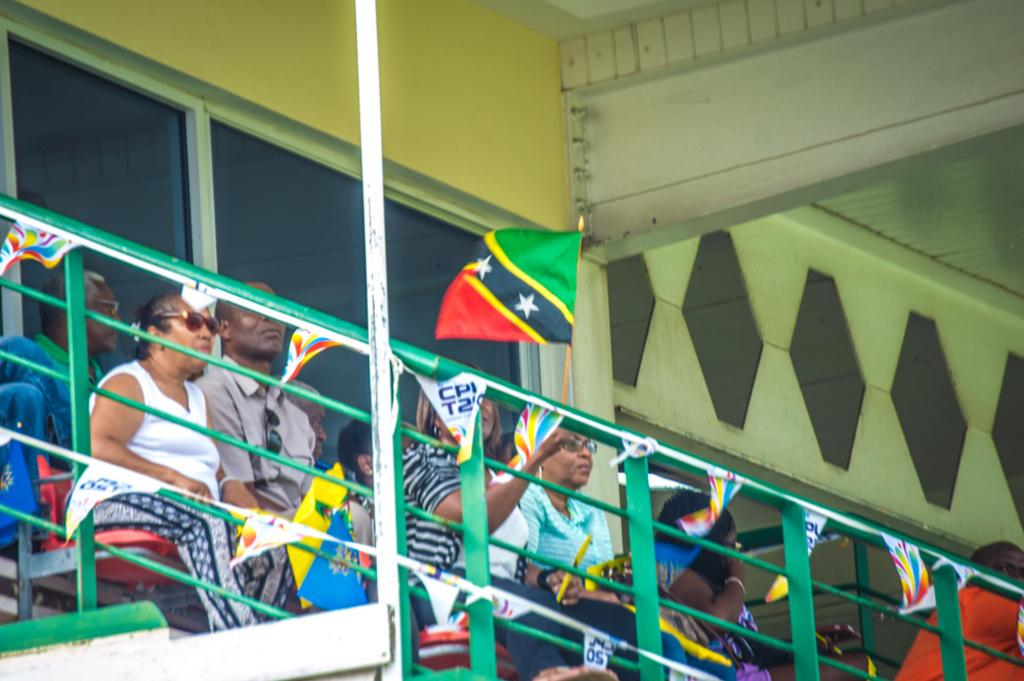<image>
Provide a brief description of the given image. A group of people are sitting in green bleachers and a small flag is hanging from them that says CPI. 